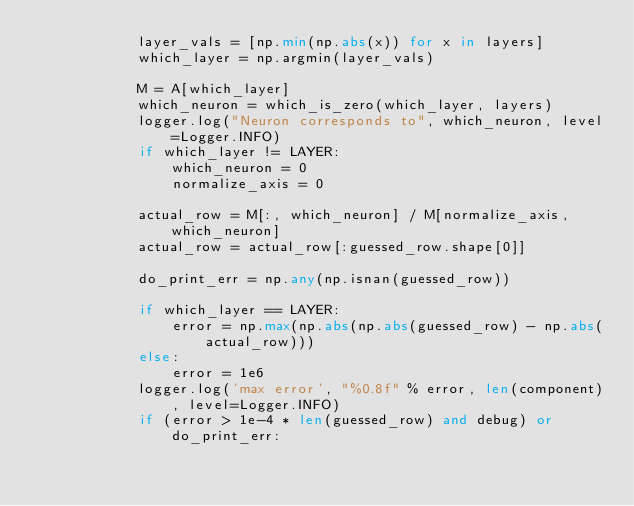Convert code to text. <code><loc_0><loc_0><loc_500><loc_500><_Python_>            layer_vals = [np.min(np.abs(x)) for x in layers]
            which_layer = np.argmin(layer_vals)

            M = A[which_layer]
            which_neuron = which_is_zero(which_layer, layers)
            logger.log("Neuron corresponds to", which_neuron, level=Logger.INFO)
            if which_layer != LAYER:
                which_neuron = 0
                normalize_axis = 0

            actual_row = M[:, which_neuron] / M[normalize_axis, which_neuron]
            actual_row = actual_row[:guessed_row.shape[0]]

            do_print_err = np.any(np.isnan(guessed_row))

            if which_layer == LAYER:
                error = np.max(np.abs(np.abs(guessed_row) - np.abs(actual_row)))
            else:
                error = 1e6
            logger.log('max error', "%0.8f" % error, len(component), level=Logger.INFO)
            if (error > 1e-4 * len(guessed_row) and debug) or do_print_err:
</code> 